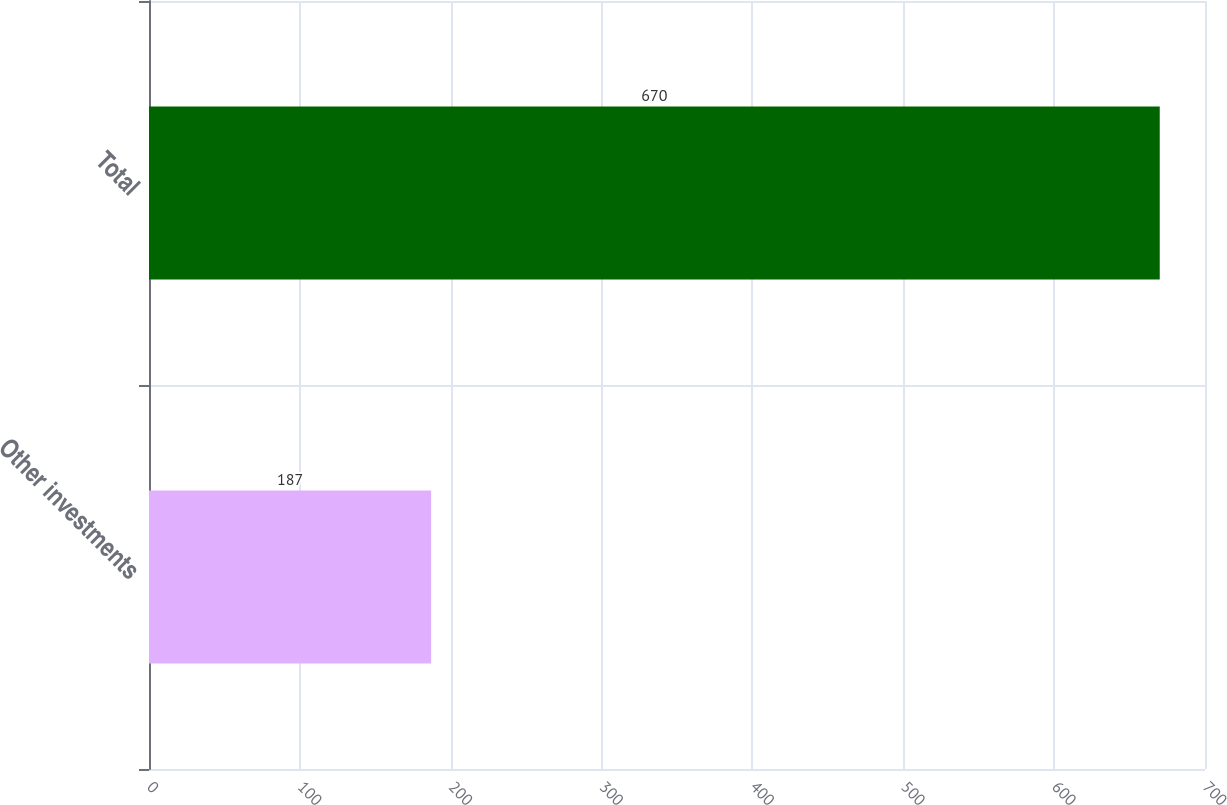Convert chart. <chart><loc_0><loc_0><loc_500><loc_500><bar_chart><fcel>Other investments<fcel>Total<nl><fcel>187<fcel>670<nl></chart> 